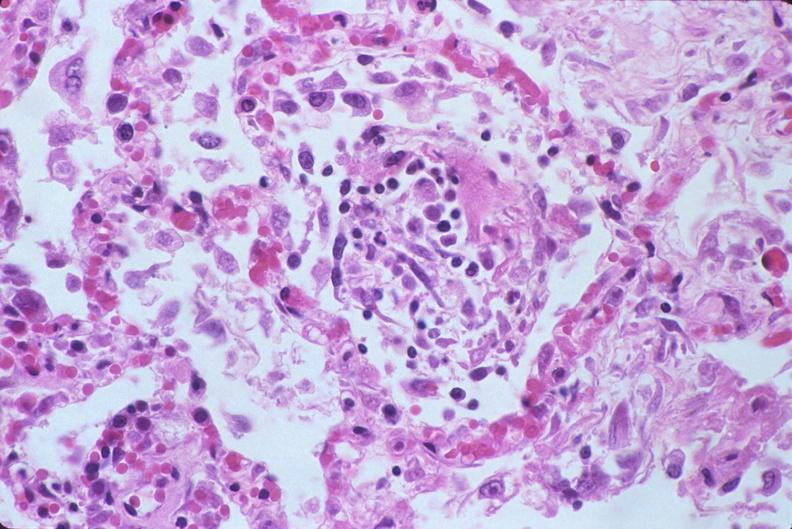where is this?
Answer the question using a single word or phrase. Lung 